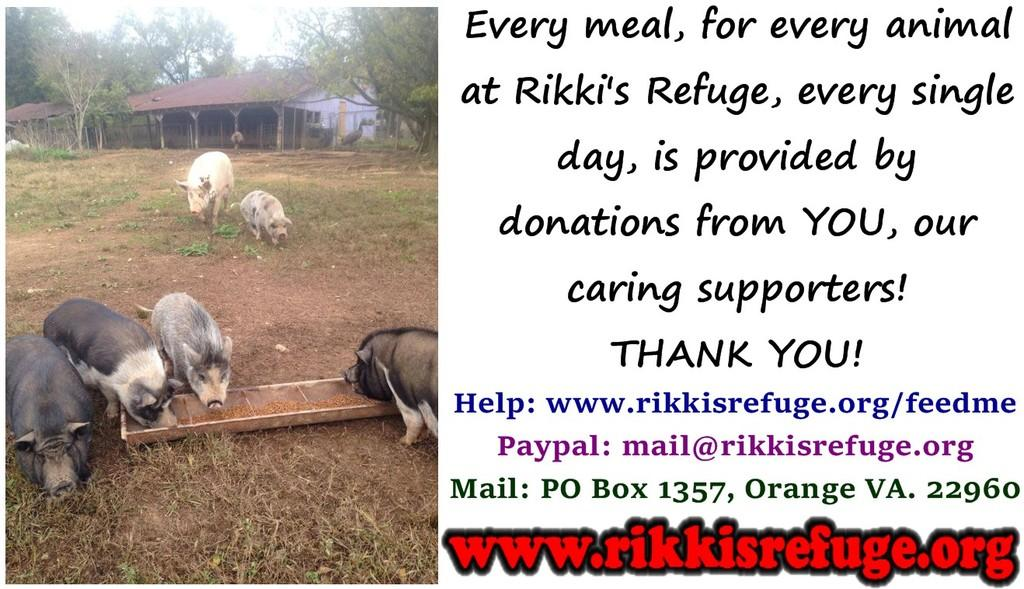What animals are present in the image? There are pigs in the image. What structures can be seen on the ground in the image? There are sheds on the ground in the image. What type of vegetation is visible in the background of the image? There are trees in the background of the image. What part of the natural environment is visible in the image? The sky is visible in the background of the image. What type of insurance policy is being discussed by the pigs in the image? There is no indication in the image that the pigs are discussing any insurance policies. 